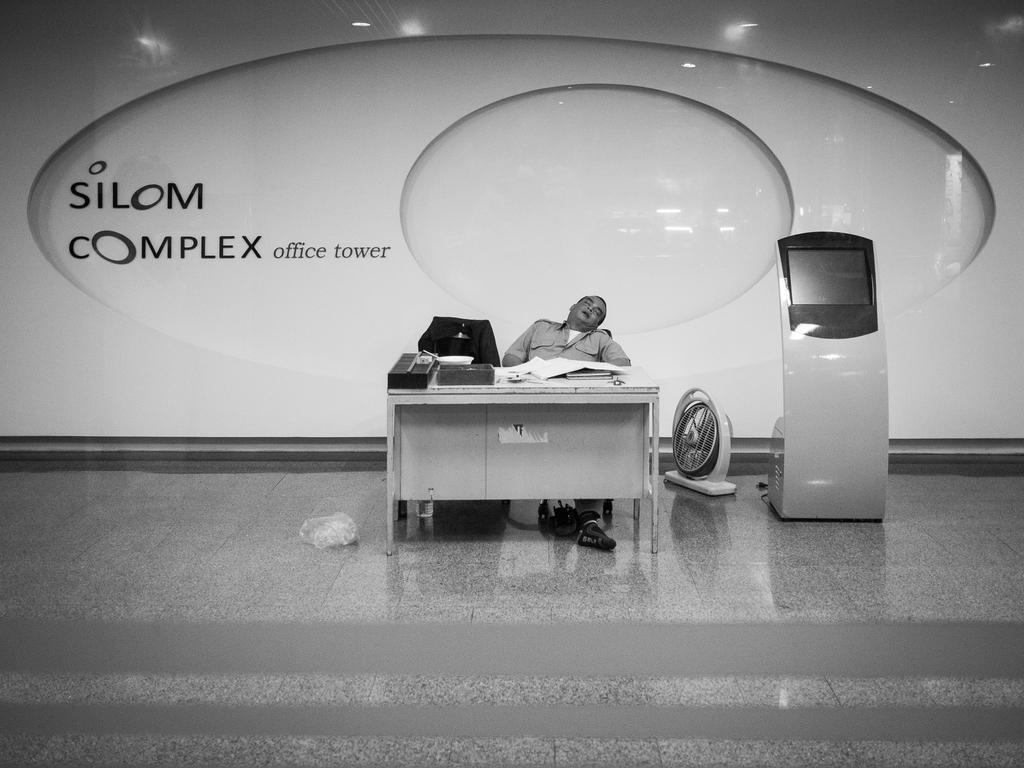What is the man in the image doing? The man is laying on a chair in the image. What objects are on the table in the image? There are papers and a box on the table in the image. What device is present in the image for cooling? There is a table fan in the image. What electronic device is visible in the image? There is a monitor in the image. What type of advertisement is displayed on the wall? There is a hoarding on the wall in the image. What grade did the man receive on his latest exam, as shown in the image? There is no information about the man's exam or grade in the image. What news is being reported on the monitor in the image? The image does not show any news being reported on the monitor; it only shows the monitor itself. 